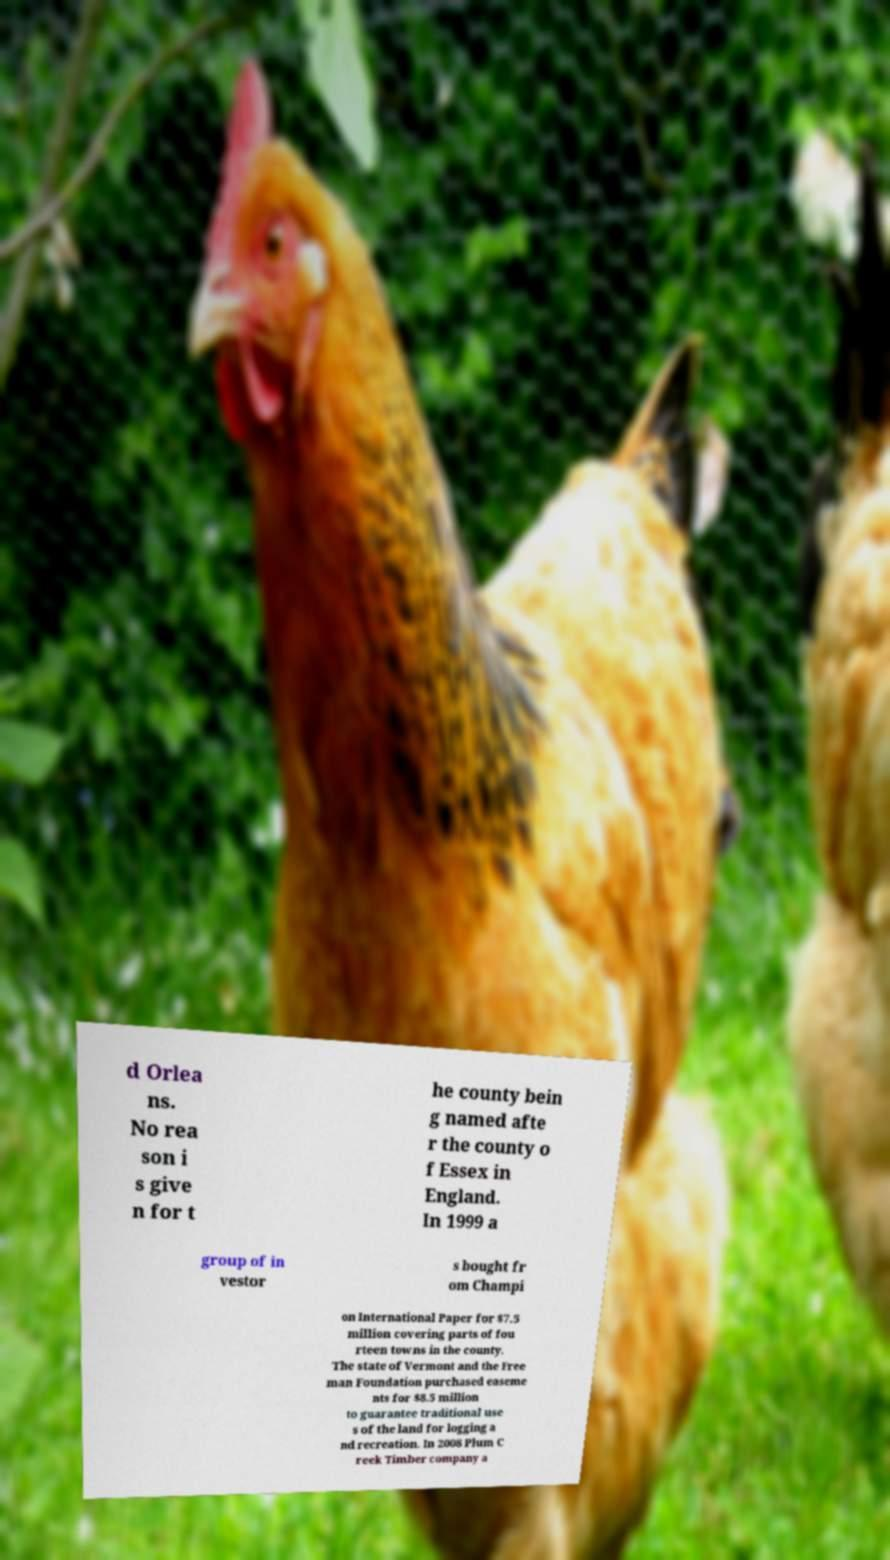What messages or text are displayed in this image? I need them in a readable, typed format. d Orlea ns. No rea son i s give n for t he county bein g named afte r the county o f Essex in England. In 1999 a group of in vestor s bought fr om Champi on International Paper for $7.5 million covering parts of fou rteen towns in the county. The state of Vermont and the Free man Foundation purchased easeme nts for $8.5 million to guarantee traditional use s of the land for logging a nd recreation. In 2008 Plum C reek Timber company a 